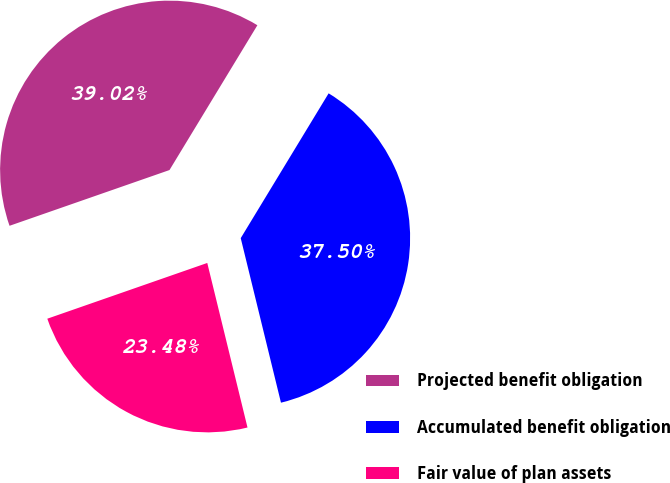<chart> <loc_0><loc_0><loc_500><loc_500><pie_chart><fcel>Projected benefit obligation<fcel>Accumulated benefit obligation<fcel>Fair value of plan assets<nl><fcel>39.02%<fcel>37.5%<fcel>23.48%<nl></chart> 